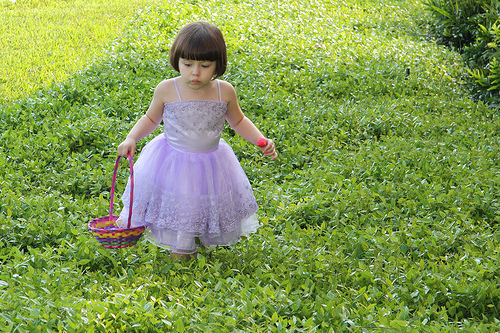<image>
Is there a baby on the grass? Yes. Looking at the image, I can see the baby is positioned on top of the grass, with the grass providing support. 